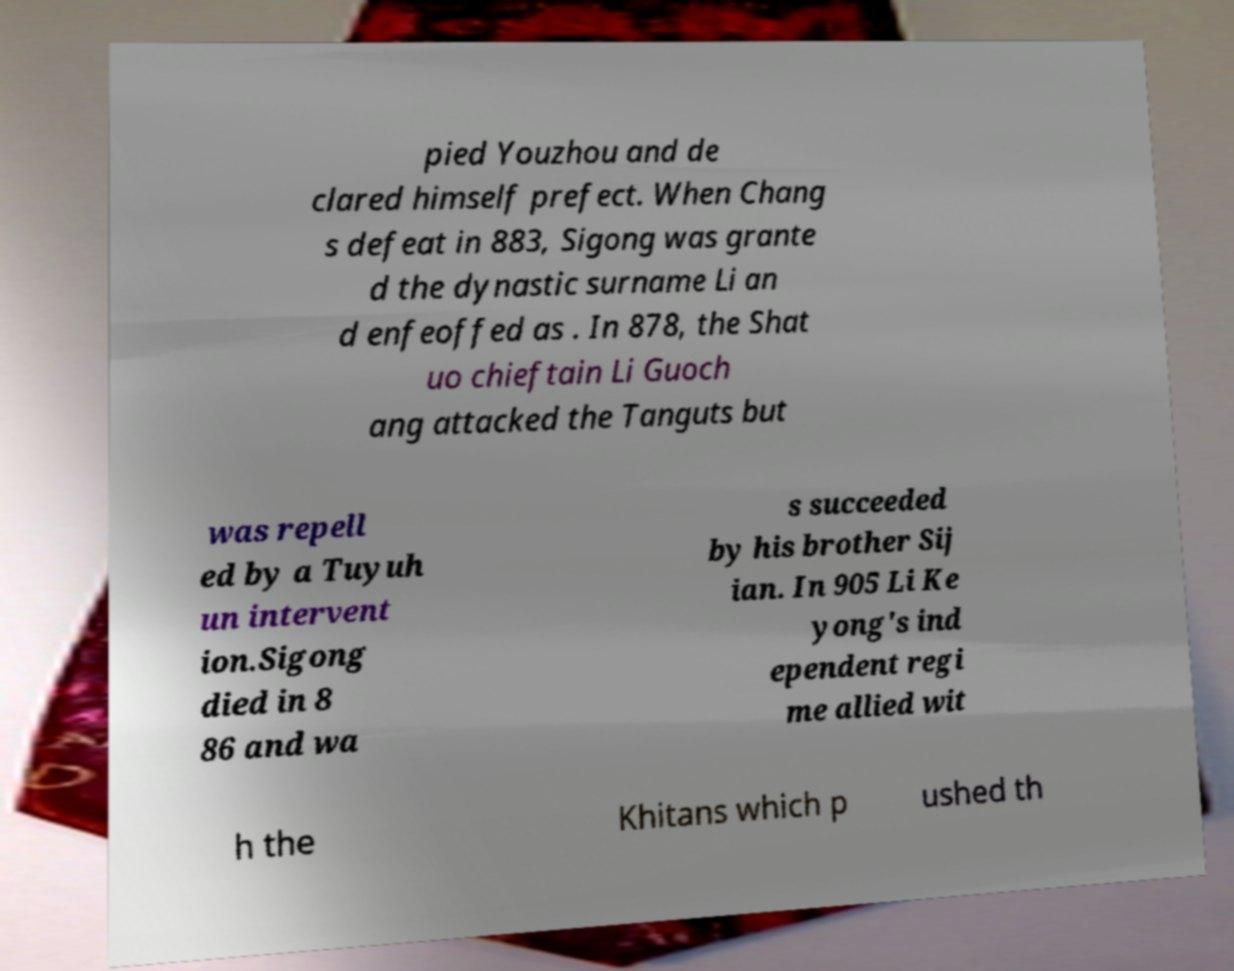Please read and relay the text visible in this image. What does it say? pied Youzhou and de clared himself prefect. When Chang s defeat in 883, Sigong was grante d the dynastic surname Li an d enfeoffed as . In 878, the Shat uo chieftain Li Guoch ang attacked the Tanguts but was repell ed by a Tuyuh un intervent ion.Sigong died in 8 86 and wa s succeeded by his brother Sij ian. In 905 Li Ke yong's ind ependent regi me allied wit h the Khitans which p ushed th 